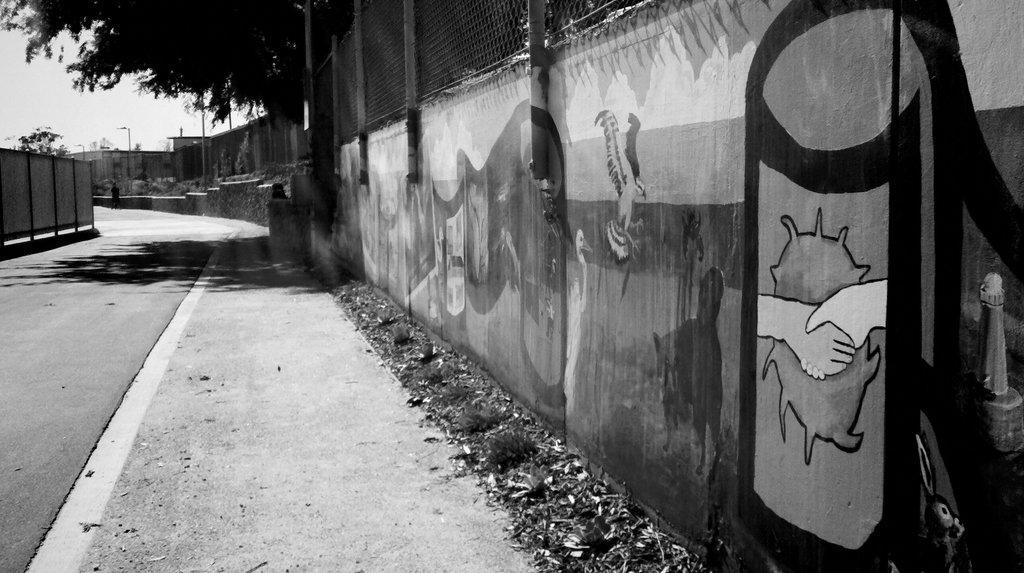In one or two sentences, can you explain what this image depicts? In this image I can see few paintings on the wall and I can also see the railing, background I can see few light poles and trees and I can also see the sky and the image is in black and white. 